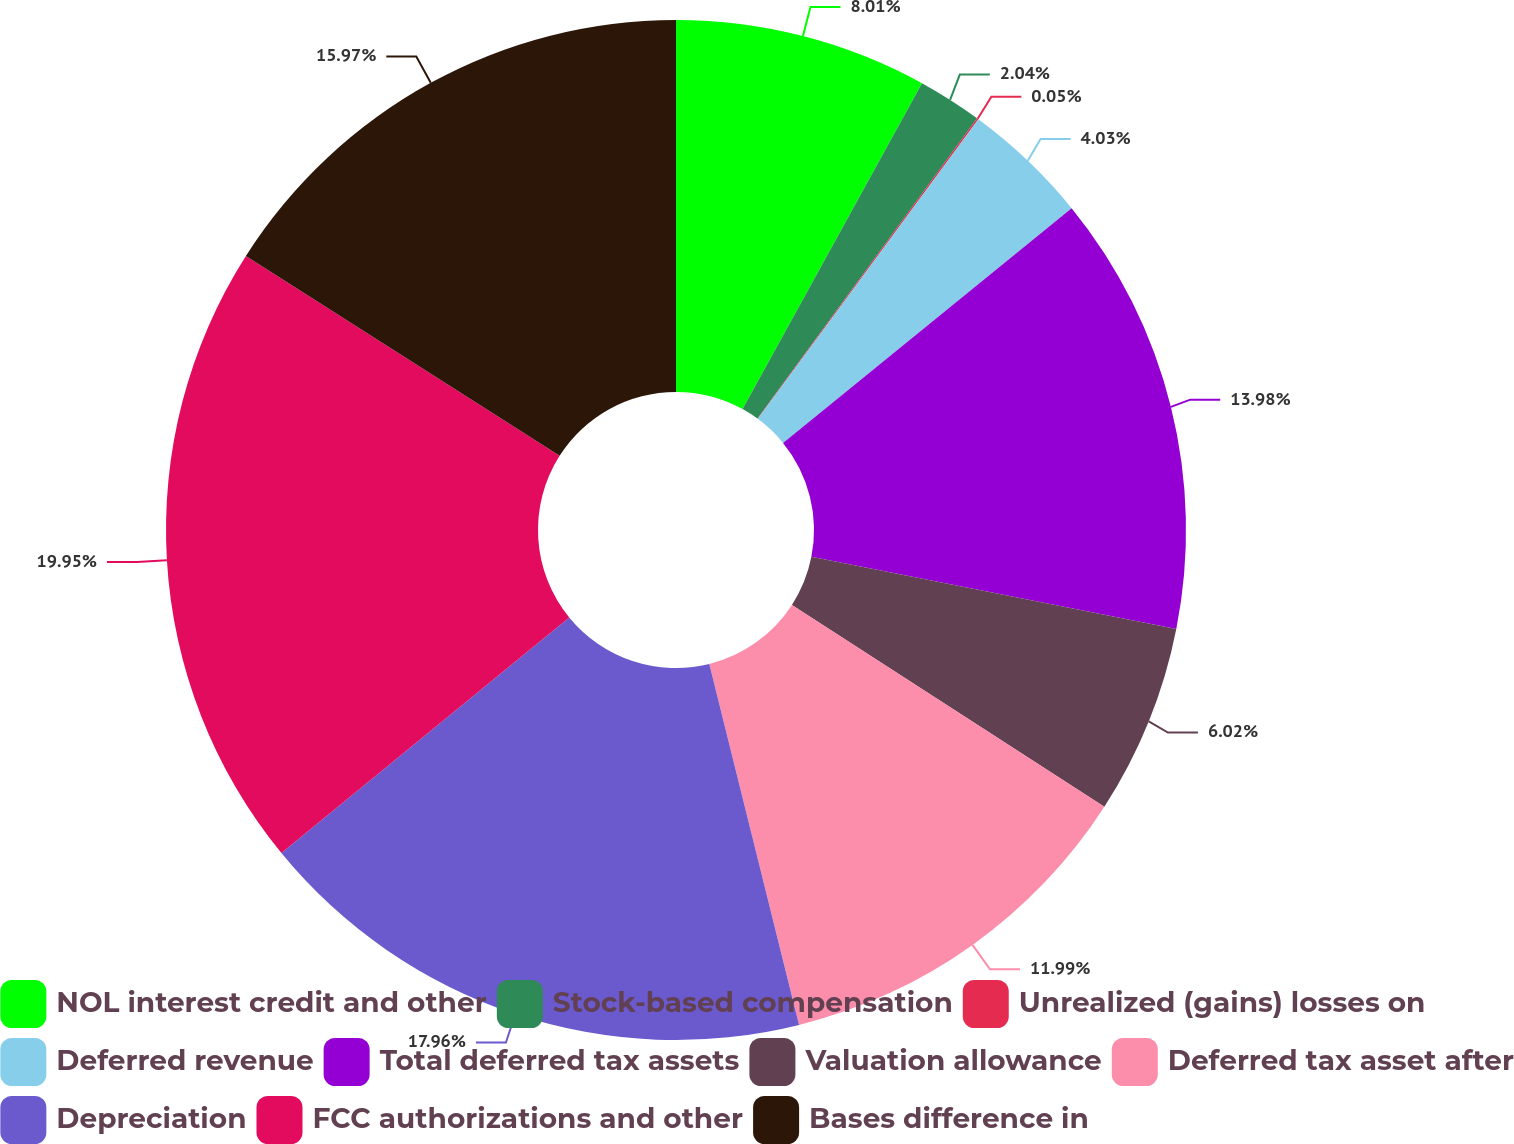<chart> <loc_0><loc_0><loc_500><loc_500><pie_chart><fcel>NOL interest credit and other<fcel>Stock-based compensation<fcel>Unrealized (gains) losses on<fcel>Deferred revenue<fcel>Total deferred tax assets<fcel>Valuation allowance<fcel>Deferred tax asset after<fcel>Depreciation<fcel>FCC authorizations and other<fcel>Bases difference in<nl><fcel>8.01%<fcel>2.04%<fcel>0.05%<fcel>4.03%<fcel>13.98%<fcel>6.02%<fcel>11.99%<fcel>17.96%<fcel>19.95%<fcel>15.97%<nl></chart> 